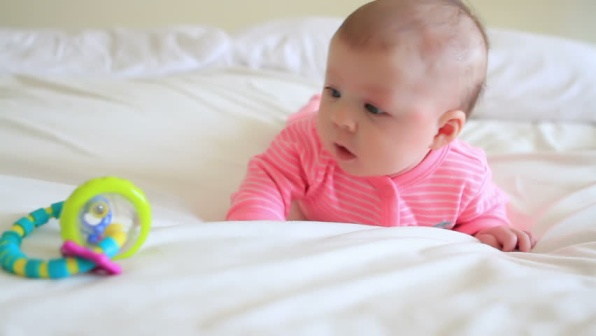What are the key elements in this picture? The image features a baby as the central focus. The baby is lying on a white bedspread that has a few wrinkles, creating a soft and cozy environment. Dressed in a pink onesie with stripes, the baby is closely observing a colorful toy placed nearby. The toy, a rattle, is predominantly yellow and blue with a playful design, grabbing the baby's attention. Positioned to the left and slightly closer to the camera, the rattle adds a touch of vibrancy to the serene setting. The overall simplicity of the scene emphasizes the baby’s curiosity and interaction with the toy, capturing a tender moment. 